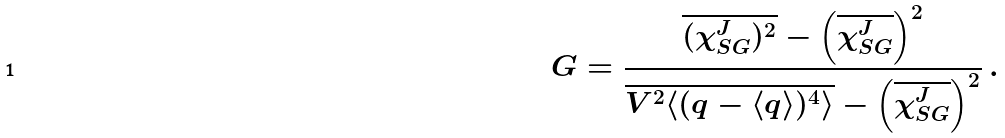Convert formula to latex. <formula><loc_0><loc_0><loc_500><loc_500>G = \frac { \overline { ( \chi _ { S G } ^ { J } ) ^ { 2 } } - \left ( \overline { \chi _ { S G } ^ { J } } \right ) ^ { 2 } } { \overline { V ^ { 2 } \langle ( q - \langle q \rangle ) ^ { 4 } \rangle } - \left ( \overline { \chi _ { S G } ^ { J } } \right ) ^ { 2 } } \, .</formula> 